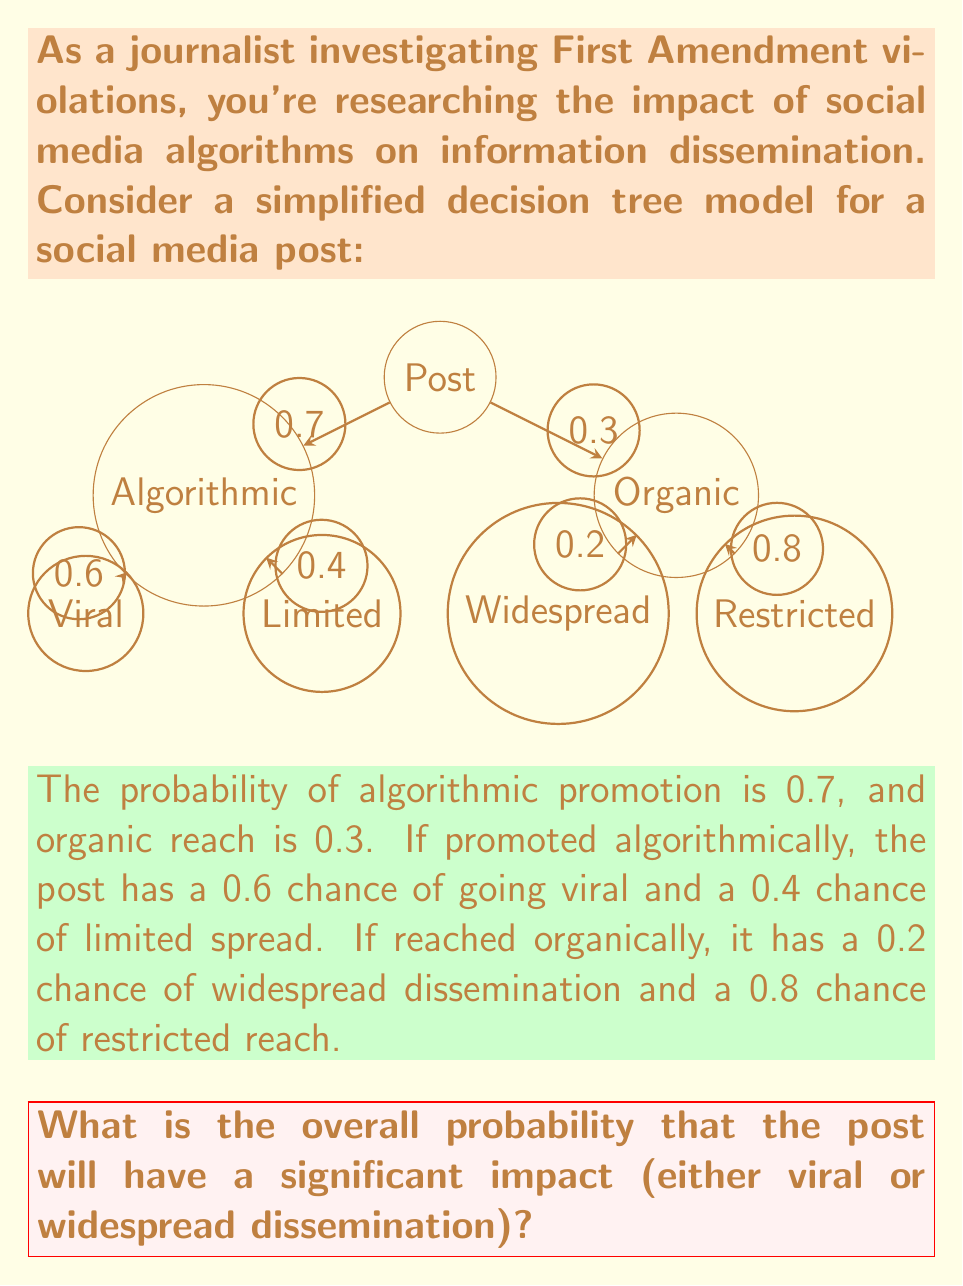Give your solution to this math problem. To solve this problem, we'll use the decision tree and the given probabilities to calculate the overall probability of significant impact. We'll follow these steps:

1. Identify the paths leading to significant impact:
   a. Algorithmic promotion → Viral
   b. Organic reach → Widespread dissemination

2. Calculate the probability for each path:
   a. P(Algorithmic and Viral) = P(Algorithmic) × P(Viral | Algorithmic)
      $$ P(\text{Algorithmic and Viral}) = 0.7 \times 0.6 = 0.42 $$
   
   b. P(Organic and Widespread) = P(Organic) × P(Widespread | Organic)
      $$ P(\text{Organic and Widespread}) = 0.3 \times 0.2 = 0.06 $$

3. Sum the probabilities of both paths to get the overall probability of significant impact:
   $$ P(\text{Significant Impact}) = P(\text{Algorithmic and Viral}) + P(\text{Organic and Widespread}) $$
   $$ P(\text{Significant Impact}) = 0.42 + 0.06 = 0.48 $$

Therefore, the overall probability that the post will have a significant impact is 0.48 or 48%.
Answer: 0.48 